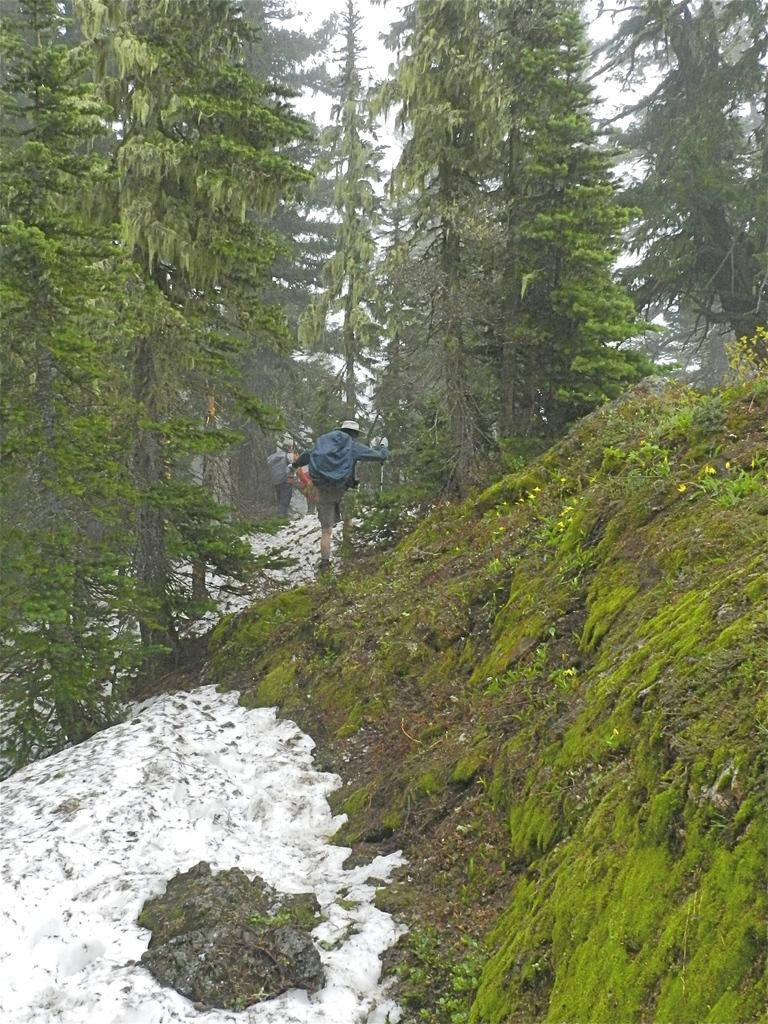What type of vegetation can be seen in the background of the image? There are trees in the background of the image. What are the people in the image doing? The people in the image are walking. What is covering the ground at the bottom of the image? There is snow at the bottom of the image. What type of vegetation is on the right side of the image? There is grass on the right side of the image. Can you see any fish swimming in the sea in the image? There is no sea or fish present in the image; it features snow, grass, trees, and people walking. What type of frame surrounds the image? The image does not have a frame; the question is not relevant to the content of the image. 